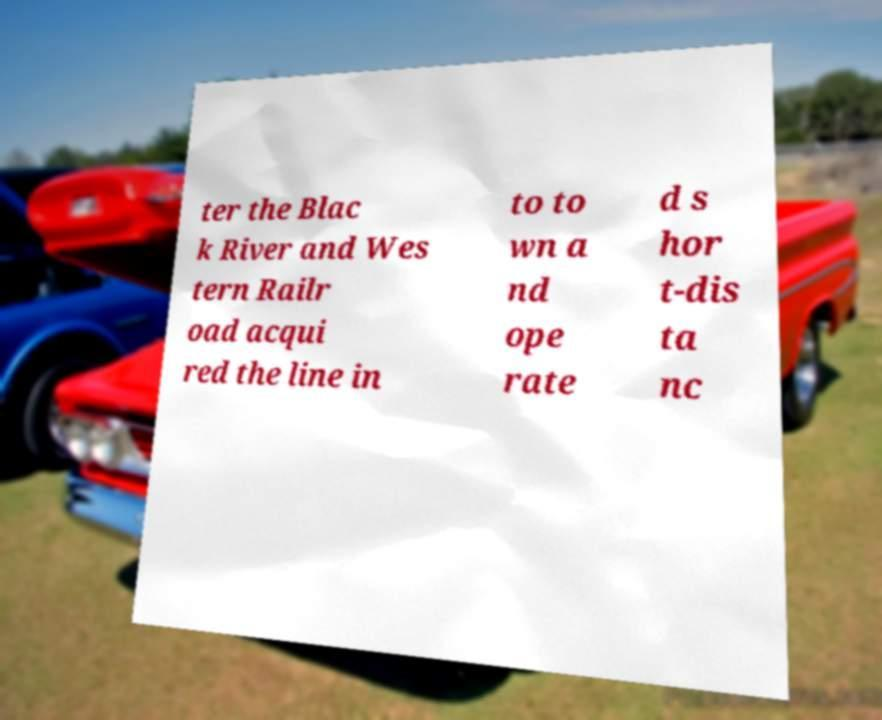Can you read and provide the text displayed in the image?This photo seems to have some interesting text. Can you extract and type it out for me? ter the Blac k River and Wes tern Railr oad acqui red the line in to to wn a nd ope rate d s hor t-dis ta nc 